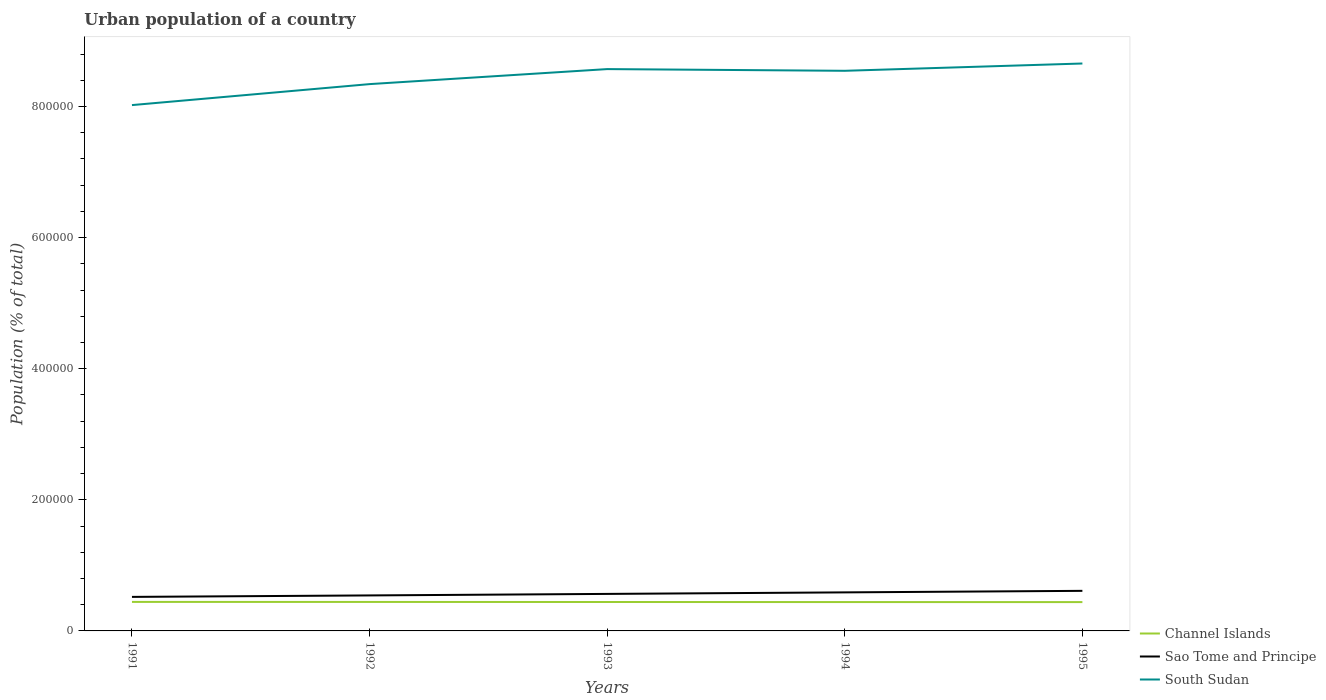How many different coloured lines are there?
Your answer should be compact. 3. Does the line corresponding to Channel Islands intersect with the line corresponding to South Sudan?
Make the answer very short. No. Is the number of lines equal to the number of legend labels?
Your answer should be compact. Yes. Across all years, what is the maximum urban population in Channel Islands?
Offer a very short reply. 4.40e+04. In which year was the urban population in South Sudan maximum?
Provide a succinct answer. 1991. What is the total urban population in Sao Tome and Principe in the graph?
Make the answer very short. -6966. What is the difference between the highest and the second highest urban population in Sao Tome and Principe?
Make the answer very short. 9211. How many lines are there?
Your answer should be very brief. 3. What is the difference between two consecutive major ticks on the Y-axis?
Your answer should be very brief. 2.00e+05. Does the graph contain any zero values?
Offer a very short reply. No. How many legend labels are there?
Your answer should be compact. 3. How are the legend labels stacked?
Offer a terse response. Vertical. What is the title of the graph?
Your response must be concise. Urban population of a country. Does "Iraq" appear as one of the legend labels in the graph?
Offer a terse response. No. What is the label or title of the X-axis?
Provide a succinct answer. Years. What is the label or title of the Y-axis?
Offer a terse response. Population (% of total). What is the Population (% of total) in Channel Islands in 1991?
Offer a terse response. 4.43e+04. What is the Population (% of total) of Sao Tome and Principe in 1991?
Keep it short and to the point. 5.19e+04. What is the Population (% of total) in South Sudan in 1991?
Give a very brief answer. 8.02e+05. What is the Population (% of total) in Channel Islands in 1992?
Offer a very short reply. 4.42e+04. What is the Population (% of total) in Sao Tome and Principe in 1992?
Offer a terse response. 5.42e+04. What is the Population (% of total) of South Sudan in 1992?
Keep it short and to the point. 8.34e+05. What is the Population (% of total) in Channel Islands in 1993?
Your answer should be very brief. 4.41e+04. What is the Population (% of total) in Sao Tome and Principe in 1993?
Offer a very short reply. 5.65e+04. What is the Population (% of total) in South Sudan in 1993?
Provide a succinct answer. 8.57e+05. What is the Population (% of total) in Channel Islands in 1994?
Offer a terse response. 4.40e+04. What is the Population (% of total) of Sao Tome and Principe in 1994?
Your answer should be very brief. 5.88e+04. What is the Population (% of total) in South Sudan in 1994?
Give a very brief answer. 8.54e+05. What is the Population (% of total) in Channel Islands in 1995?
Make the answer very short. 4.40e+04. What is the Population (% of total) in Sao Tome and Principe in 1995?
Your answer should be compact. 6.11e+04. What is the Population (% of total) of South Sudan in 1995?
Offer a terse response. 8.66e+05. Across all years, what is the maximum Population (% of total) of Channel Islands?
Your answer should be compact. 4.43e+04. Across all years, what is the maximum Population (% of total) of Sao Tome and Principe?
Ensure brevity in your answer.  6.11e+04. Across all years, what is the maximum Population (% of total) in South Sudan?
Make the answer very short. 8.66e+05. Across all years, what is the minimum Population (% of total) in Channel Islands?
Provide a succinct answer. 4.40e+04. Across all years, what is the minimum Population (% of total) in Sao Tome and Principe?
Keep it short and to the point. 5.19e+04. Across all years, what is the minimum Population (% of total) of South Sudan?
Offer a terse response. 8.02e+05. What is the total Population (% of total) of Channel Islands in the graph?
Give a very brief answer. 2.21e+05. What is the total Population (% of total) in Sao Tome and Principe in the graph?
Provide a succinct answer. 2.82e+05. What is the total Population (% of total) of South Sudan in the graph?
Your response must be concise. 4.21e+06. What is the difference between the Population (% of total) of Channel Islands in 1991 and that in 1992?
Your answer should be compact. 49. What is the difference between the Population (% of total) in Sao Tome and Principe in 1991 and that in 1992?
Provide a succinct answer. -2245. What is the difference between the Population (% of total) in South Sudan in 1991 and that in 1992?
Make the answer very short. -3.20e+04. What is the difference between the Population (% of total) in Channel Islands in 1991 and that in 1993?
Your answer should be very brief. 138. What is the difference between the Population (% of total) in Sao Tome and Principe in 1991 and that in 1993?
Provide a succinct answer. -4542. What is the difference between the Population (% of total) of South Sudan in 1991 and that in 1993?
Ensure brevity in your answer.  -5.49e+04. What is the difference between the Population (% of total) in Channel Islands in 1991 and that in 1994?
Make the answer very short. 228. What is the difference between the Population (% of total) in Sao Tome and Principe in 1991 and that in 1994?
Ensure brevity in your answer.  -6874. What is the difference between the Population (% of total) of South Sudan in 1991 and that in 1994?
Keep it short and to the point. -5.23e+04. What is the difference between the Population (% of total) in Channel Islands in 1991 and that in 1995?
Offer a very short reply. 290. What is the difference between the Population (% of total) in Sao Tome and Principe in 1991 and that in 1995?
Make the answer very short. -9211. What is the difference between the Population (% of total) in South Sudan in 1991 and that in 1995?
Ensure brevity in your answer.  -6.34e+04. What is the difference between the Population (% of total) of Channel Islands in 1992 and that in 1993?
Provide a short and direct response. 89. What is the difference between the Population (% of total) in Sao Tome and Principe in 1992 and that in 1993?
Your answer should be very brief. -2297. What is the difference between the Population (% of total) of South Sudan in 1992 and that in 1993?
Your response must be concise. -2.29e+04. What is the difference between the Population (% of total) in Channel Islands in 1992 and that in 1994?
Your response must be concise. 179. What is the difference between the Population (% of total) of Sao Tome and Principe in 1992 and that in 1994?
Provide a succinct answer. -4629. What is the difference between the Population (% of total) of South Sudan in 1992 and that in 1994?
Your response must be concise. -2.03e+04. What is the difference between the Population (% of total) of Channel Islands in 1992 and that in 1995?
Ensure brevity in your answer.  241. What is the difference between the Population (% of total) of Sao Tome and Principe in 1992 and that in 1995?
Offer a terse response. -6966. What is the difference between the Population (% of total) in South Sudan in 1992 and that in 1995?
Provide a succinct answer. -3.14e+04. What is the difference between the Population (% of total) in Sao Tome and Principe in 1993 and that in 1994?
Provide a succinct answer. -2332. What is the difference between the Population (% of total) in South Sudan in 1993 and that in 1994?
Offer a very short reply. 2589. What is the difference between the Population (% of total) of Channel Islands in 1993 and that in 1995?
Provide a short and direct response. 152. What is the difference between the Population (% of total) of Sao Tome and Principe in 1993 and that in 1995?
Give a very brief answer. -4669. What is the difference between the Population (% of total) in South Sudan in 1993 and that in 1995?
Offer a very short reply. -8530. What is the difference between the Population (% of total) in Channel Islands in 1994 and that in 1995?
Your response must be concise. 62. What is the difference between the Population (% of total) in Sao Tome and Principe in 1994 and that in 1995?
Offer a terse response. -2337. What is the difference between the Population (% of total) of South Sudan in 1994 and that in 1995?
Your response must be concise. -1.11e+04. What is the difference between the Population (% of total) in Channel Islands in 1991 and the Population (% of total) in Sao Tome and Principe in 1992?
Offer a very short reply. -9903. What is the difference between the Population (% of total) in Channel Islands in 1991 and the Population (% of total) in South Sudan in 1992?
Offer a terse response. -7.90e+05. What is the difference between the Population (% of total) of Sao Tome and Principe in 1991 and the Population (% of total) of South Sudan in 1992?
Ensure brevity in your answer.  -7.82e+05. What is the difference between the Population (% of total) in Channel Islands in 1991 and the Population (% of total) in Sao Tome and Principe in 1993?
Provide a succinct answer. -1.22e+04. What is the difference between the Population (% of total) in Channel Islands in 1991 and the Population (% of total) in South Sudan in 1993?
Make the answer very short. -8.13e+05. What is the difference between the Population (% of total) in Sao Tome and Principe in 1991 and the Population (% of total) in South Sudan in 1993?
Your answer should be very brief. -8.05e+05. What is the difference between the Population (% of total) in Channel Islands in 1991 and the Population (% of total) in Sao Tome and Principe in 1994?
Offer a very short reply. -1.45e+04. What is the difference between the Population (% of total) in Channel Islands in 1991 and the Population (% of total) in South Sudan in 1994?
Offer a very short reply. -8.10e+05. What is the difference between the Population (% of total) in Sao Tome and Principe in 1991 and the Population (% of total) in South Sudan in 1994?
Ensure brevity in your answer.  -8.02e+05. What is the difference between the Population (% of total) in Channel Islands in 1991 and the Population (% of total) in Sao Tome and Principe in 1995?
Your answer should be very brief. -1.69e+04. What is the difference between the Population (% of total) of Channel Islands in 1991 and the Population (% of total) of South Sudan in 1995?
Give a very brief answer. -8.21e+05. What is the difference between the Population (% of total) of Sao Tome and Principe in 1991 and the Population (% of total) of South Sudan in 1995?
Make the answer very short. -8.14e+05. What is the difference between the Population (% of total) in Channel Islands in 1992 and the Population (% of total) in Sao Tome and Principe in 1993?
Give a very brief answer. -1.22e+04. What is the difference between the Population (% of total) of Channel Islands in 1992 and the Population (% of total) of South Sudan in 1993?
Ensure brevity in your answer.  -8.13e+05. What is the difference between the Population (% of total) of Sao Tome and Principe in 1992 and the Population (% of total) of South Sudan in 1993?
Give a very brief answer. -8.03e+05. What is the difference between the Population (% of total) in Channel Islands in 1992 and the Population (% of total) in Sao Tome and Principe in 1994?
Offer a terse response. -1.46e+04. What is the difference between the Population (% of total) in Channel Islands in 1992 and the Population (% of total) in South Sudan in 1994?
Make the answer very short. -8.10e+05. What is the difference between the Population (% of total) in Sao Tome and Principe in 1992 and the Population (% of total) in South Sudan in 1994?
Ensure brevity in your answer.  -8.00e+05. What is the difference between the Population (% of total) in Channel Islands in 1992 and the Population (% of total) in Sao Tome and Principe in 1995?
Give a very brief answer. -1.69e+04. What is the difference between the Population (% of total) of Channel Islands in 1992 and the Population (% of total) of South Sudan in 1995?
Your response must be concise. -8.21e+05. What is the difference between the Population (% of total) of Sao Tome and Principe in 1992 and the Population (% of total) of South Sudan in 1995?
Offer a terse response. -8.11e+05. What is the difference between the Population (% of total) of Channel Islands in 1993 and the Population (% of total) of Sao Tome and Principe in 1994?
Make the answer very short. -1.47e+04. What is the difference between the Population (% of total) in Channel Islands in 1993 and the Population (% of total) in South Sudan in 1994?
Offer a very short reply. -8.10e+05. What is the difference between the Population (% of total) of Sao Tome and Principe in 1993 and the Population (% of total) of South Sudan in 1994?
Give a very brief answer. -7.98e+05. What is the difference between the Population (% of total) of Channel Islands in 1993 and the Population (% of total) of Sao Tome and Principe in 1995?
Offer a very short reply. -1.70e+04. What is the difference between the Population (% of total) in Channel Islands in 1993 and the Population (% of total) in South Sudan in 1995?
Offer a terse response. -8.21e+05. What is the difference between the Population (% of total) of Sao Tome and Principe in 1993 and the Population (% of total) of South Sudan in 1995?
Ensure brevity in your answer.  -8.09e+05. What is the difference between the Population (% of total) in Channel Islands in 1994 and the Population (% of total) in Sao Tome and Principe in 1995?
Give a very brief answer. -1.71e+04. What is the difference between the Population (% of total) of Channel Islands in 1994 and the Population (% of total) of South Sudan in 1995?
Offer a terse response. -8.21e+05. What is the difference between the Population (% of total) in Sao Tome and Principe in 1994 and the Population (% of total) in South Sudan in 1995?
Keep it short and to the point. -8.07e+05. What is the average Population (% of total) of Channel Islands per year?
Ensure brevity in your answer.  4.41e+04. What is the average Population (% of total) of Sao Tome and Principe per year?
Your answer should be compact. 5.65e+04. What is the average Population (% of total) in South Sudan per year?
Provide a succinct answer. 8.43e+05. In the year 1991, what is the difference between the Population (% of total) of Channel Islands and Population (% of total) of Sao Tome and Principe?
Offer a very short reply. -7658. In the year 1991, what is the difference between the Population (% of total) in Channel Islands and Population (% of total) in South Sudan?
Provide a succinct answer. -7.58e+05. In the year 1991, what is the difference between the Population (% of total) in Sao Tome and Principe and Population (% of total) in South Sudan?
Provide a succinct answer. -7.50e+05. In the year 1992, what is the difference between the Population (% of total) in Channel Islands and Population (% of total) in Sao Tome and Principe?
Provide a short and direct response. -9952. In the year 1992, what is the difference between the Population (% of total) of Channel Islands and Population (% of total) of South Sudan?
Your response must be concise. -7.90e+05. In the year 1992, what is the difference between the Population (% of total) of Sao Tome and Principe and Population (% of total) of South Sudan?
Offer a terse response. -7.80e+05. In the year 1993, what is the difference between the Population (% of total) of Channel Islands and Population (% of total) of Sao Tome and Principe?
Offer a very short reply. -1.23e+04. In the year 1993, what is the difference between the Population (% of total) of Channel Islands and Population (% of total) of South Sudan?
Provide a short and direct response. -8.13e+05. In the year 1993, what is the difference between the Population (% of total) of Sao Tome and Principe and Population (% of total) of South Sudan?
Offer a terse response. -8.01e+05. In the year 1994, what is the difference between the Population (% of total) of Channel Islands and Population (% of total) of Sao Tome and Principe?
Keep it short and to the point. -1.48e+04. In the year 1994, what is the difference between the Population (% of total) in Channel Islands and Population (% of total) in South Sudan?
Make the answer very short. -8.10e+05. In the year 1994, what is the difference between the Population (% of total) in Sao Tome and Principe and Population (% of total) in South Sudan?
Provide a short and direct response. -7.96e+05. In the year 1995, what is the difference between the Population (% of total) in Channel Islands and Population (% of total) in Sao Tome and Principe?
Your response must be concise. -1.72e+04. In the year 1995, what is the difference between the Population (% of total) in Channel Islands and Population (% of total) in South Sudan?
Keep it short and to the point. -8.22e+05. In the year 1995, what is the difference between the Population (% of total) in Sao Tome and Principe and Population (% of total) in South Sudan?
Ensure brevity in your answer.  -8.04e+05. What is the ratio of the Population (% of total) of Sao Tome and Principe in 1991 to that in 1992?
Your response must be concise. 0.96. What is the ratio of the Population (% of total) in South Sudan in 1991 to that in 1992?
Your answer should be very brief. 0.96. What is the ratio of the Population (% of total) in Sao Tome and Principe in 1991 to that in 1993?
Make the answer very short. 0.92. What is the ratio of the Population (% of total) in South Sudan in 1991 to that in 1993?
Your answer should be very brief. 0.94. What is the ratio of the Population (% of total) in Sao Tome and Principe in 1991 to that in 1994?
Provide a succinct answer. 0.88. What is the ratio of the Population (% of total) in South Sudan in 1991 to that in 1994?
Ensure brevity in your answer.  0.94. What is the ratio of the Population (% of total) in Channel Islands in 1991 to that in 1995?
Provide a succinct answer. 1.01. What is the ratio of the Population (% of total) of Sao Tome and Principe in 1991 to that in 1995?
Provide a succinct answer. 0.85. What is the ratio of the Population (% of total) of South Sudan in 1991 to that in 1995?
Your response must be concise. 0.93. What is the ratio of the Population (% of total) of Sao Tome and Principe in 1992 to that in 1993?
Provide a short and direct response. 0.96. What is the ratio of the Population (% of total) of South Sudan in 1992 to that in 1993?
Your response must be concise. 0.97. What is the ratio of the Population (% of total) in Channel Islands in 1992 to that in 1994?
Offer a very short reply. 1. What is the ratio of the Population (% of total) in Sao Tome and Principe in 1992 to that in 1994?
Your answer should be very brief. 0.92. What is the ratio of the Population (% of total) of South Sudan in 1992 to that in 1994?
Provide a short and direct response. 0.98. What is the ratio of the Population (% of total) of Channel Islands in 1992 to that in 1995?
Make the answer very short. 1.01. What is the ratio of the Population (% of total) of Sao Tome and Principe in 1992 to that in 1995?
Give a very brief answer. 0.89. What is the ratio of the Population (% of total) in South Sudan in 1992 to that in 1995?
Offer a very short reply. 0.96. What is the ratio of the Population (% of total) in Sao Tome and Principe in 1993 to that in 1994?
Make the answer very short. 0.96. What is the ratio of the Population (% of total) of South Sudan in 1993 to that in 1994?
Your answer should be compact. 1. What is the ratio of the Population (% of total) in Channel Islands in 1993 to that in 1995?
Give a very brief answer. 1. What is the ratio of the Population (% of total) of Sao Tome and Principe in 1993 to that in 1995?
Offer a terse response. 0.92. What is the ratio of the Population (% of total) of South Sudan in 1993 to that in 1995?
Provide a succinct answer. 0.99. What is the ratio of the Population (% of total) in Sao Tome and Principe in 1994 to that in 1995?
Give a very brief answer. 0.96. What is the ratio of the Population (% of total) in South Sudan in 1994 to that in 1995?
Your response must be concise. 0.99. What is the difference between the highest and the second highest Population (% of total) of Channel Islands?
Your answer should be very brief. 49. What is the difference between the highest and the second highest Population (% of total) of Sao Tome and Principe?
Offer a very short reply. 2337. What is the difference between the highest and the second highest Population (% of total) in South Sudan?
Provide a succinct answer. 8530. What is the difference between the highest and the lowest Population (% of total) of Channel Islands?
Offer a very short reply. 290. What is the difference between the highest and the lowest Population (% of total) of Sao Tome and Principe?
Your answer should be very brief. 9211. What is the difference between the highest and the lowest Population (% of total) in South Sudan?
Your response must be concise. 6.34e+04. 